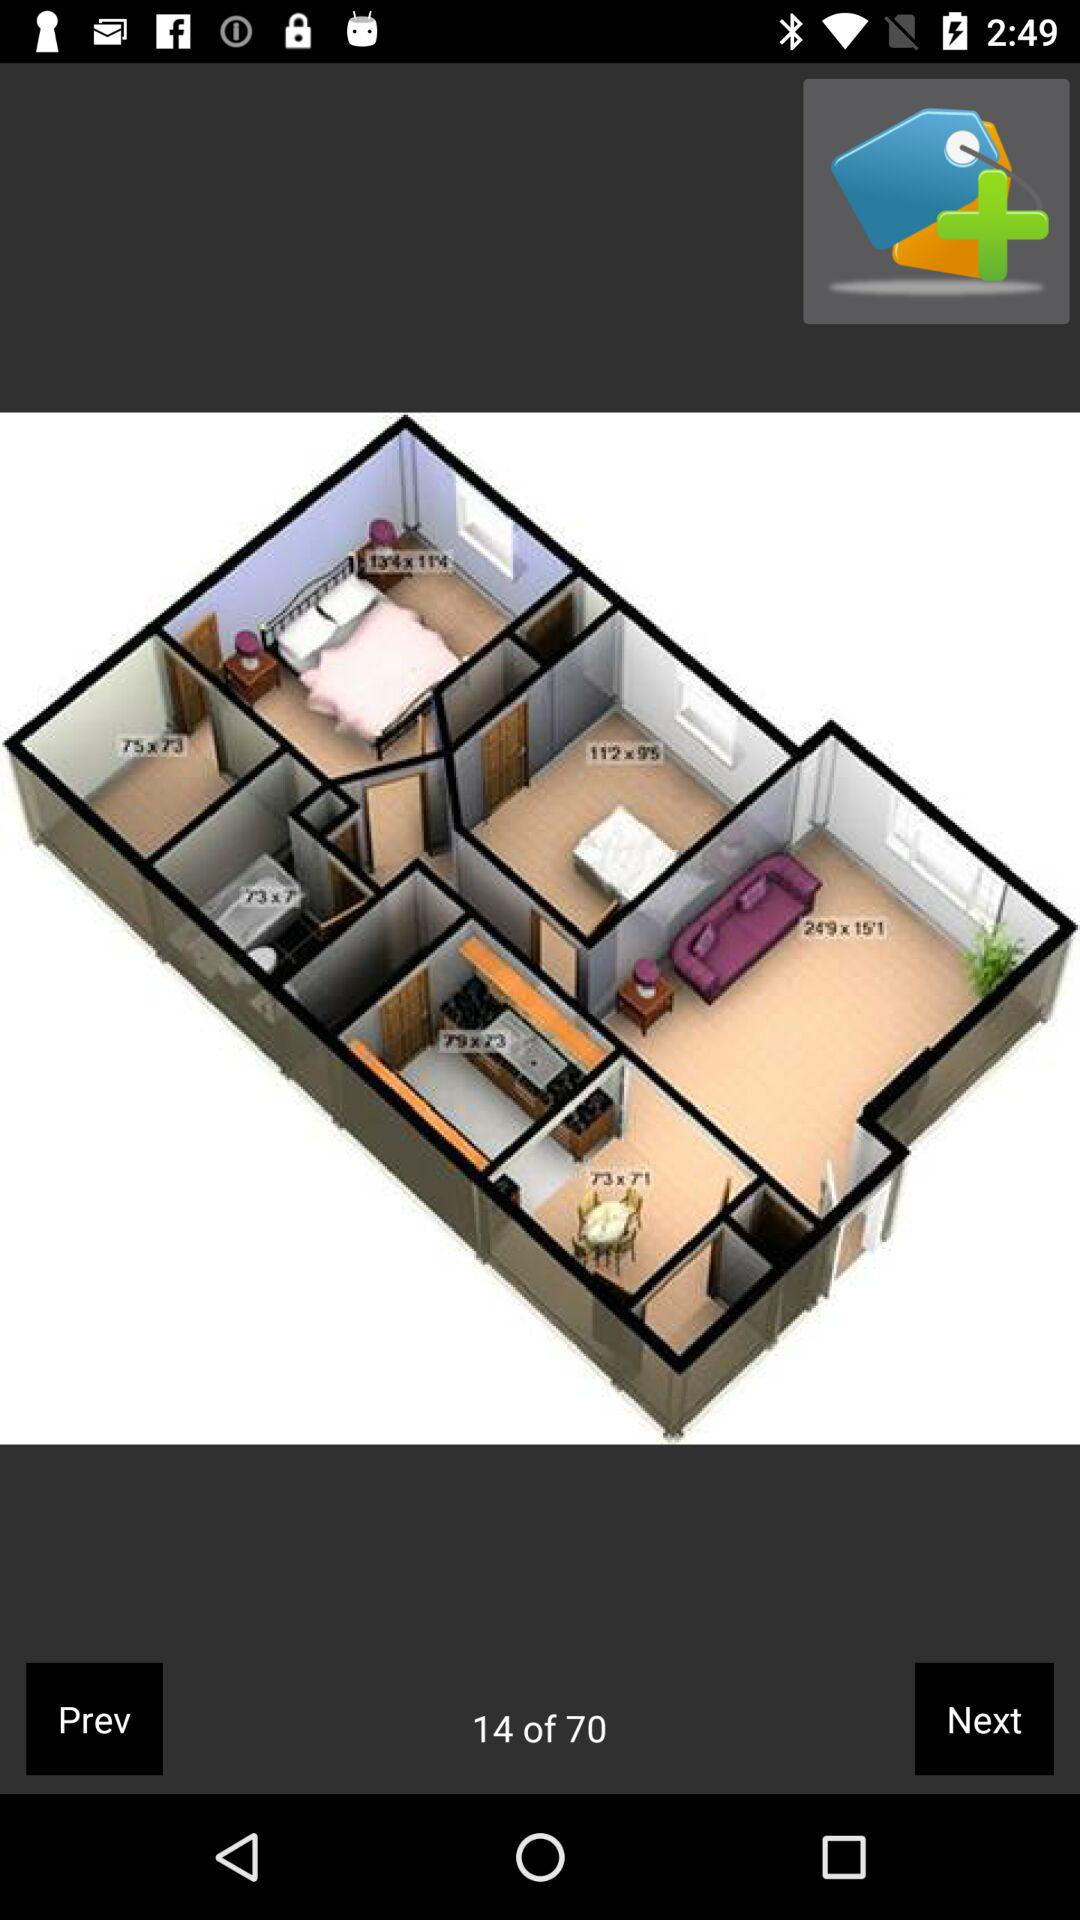How many slides in total are there? There are 70 slides in total. 